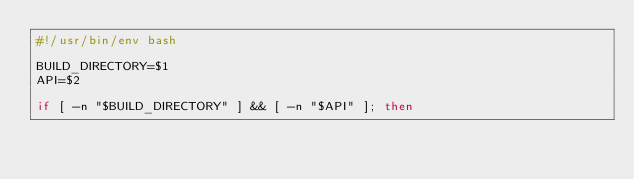<code> <loc_0><loc_0><loc_500><loc_500><_Bash_>#!/usr/bin/env bash

BUILD_DIRECTORY=$1
API=$2

if [ -n "$BUILD_DIRECTORY" ] && [ -n "$API" ]; then</code> 